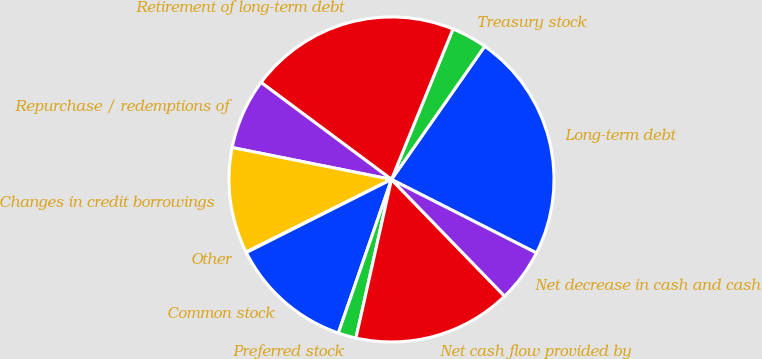Convert chart to OTSL. <chart><loc_0><loc_0><loc_500><loc_500><pie_chart><fcel>Long-term debt<fcel>Treasury stock<fcel>Retirement of long-term debt<fcel>Repurchase / redemptions of<fcel>Changes in credit borrowings<fcel>Other<fcel>Common stock<fcel>Preferred stock<fcel>Net cash flow provided by<fcel>Net decrease in cash and cash<nl><fcel>22.75%<fcel>3.54%<fcel>21.0%<fcel>7.03%<fcel>10.52%<fcel>0.05%<fcel>12.27%<fcel>1.79%<fcel>15.76%<fcel>5.28%<nl></chart> 